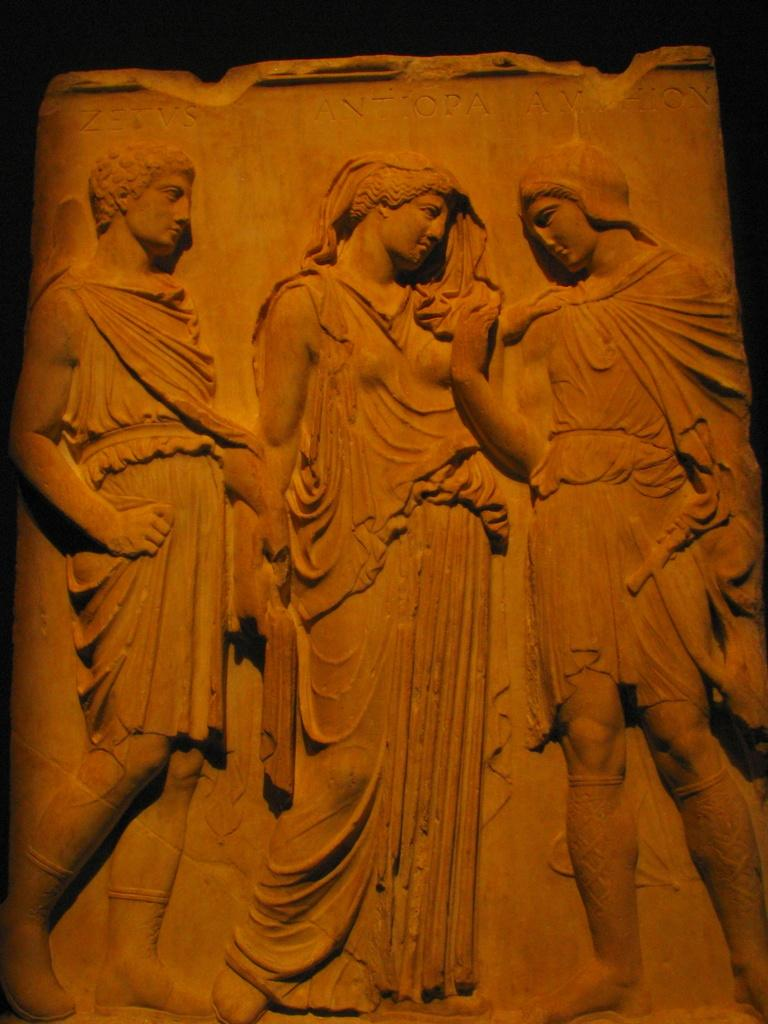What type of artwork is depicted on the wall in the image? There are sculptures of persons on the wall in the image. What can be observed about the overall color scheme of the image? The background of the image is dark in color. What type of vest is hanging on the rod near the faucet in the image? There is no vest, rod, or faucet present in the image. 